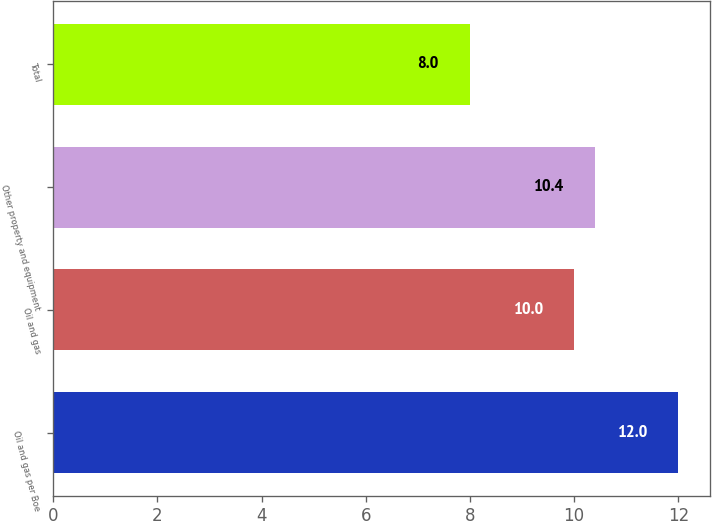Convert chart. <chart><loc_0><loc_0><loc_500><loc_500><bar_chart><fcel>Oil and gas per Boe<fcel>Oil and gas<fcel>Other property and equipment<fcel>Total<nl><fcel>12<fcel>10<fcel>10.4<fcel>8<nl></chart> 